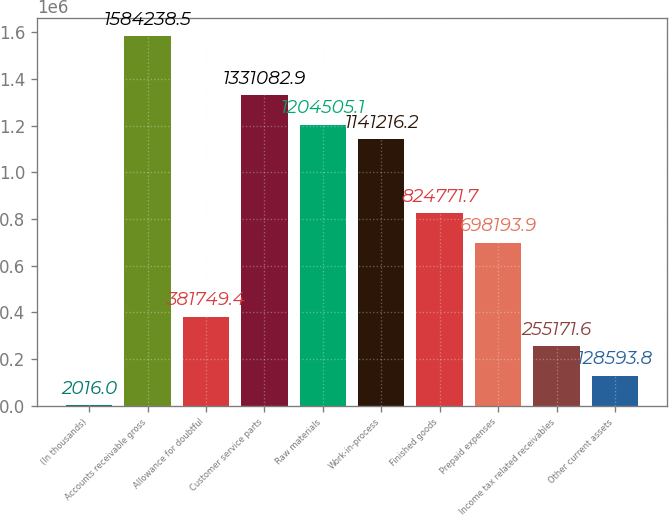Convert chart to OTSL. <chart><loc_0><loc_0><loc_500><loc_500><bar_chart><fcel>(In thousands)<fcel>Accounts receivable gross<fcel>Allowance for doubtful<fcel>Customer service parts<fcel>Raw materials<fcel>Work-in-process<fcel>Finished goods<fcel>Prepaid expenses<fcel>Income tax related receivables<fcel>Other current assets<nl><fcel>2016<fcel>1.58424e+06<fcel>381749<fcel>1.33108e+06<fcel>1.20451e+06<fcel>1.14122e+06<fcel>824772<fcel>698194<fcel>255172<fcel>128594<nl></chart> 